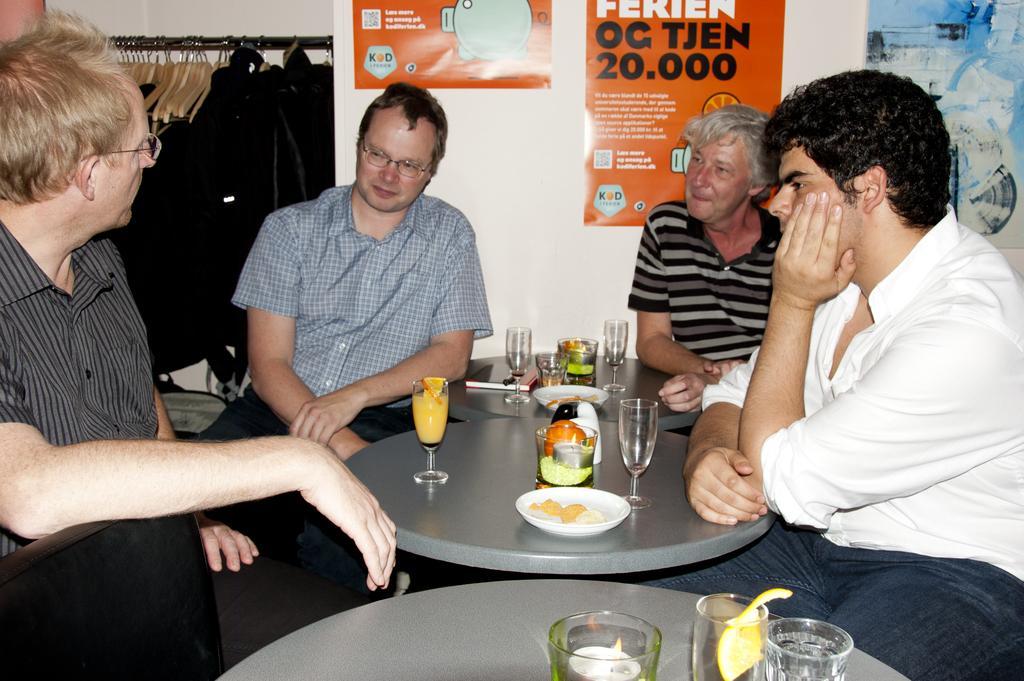In one or two sentences, can you explain what this image depicts? In this image we can see men sitting on the chairs and tables are placed in front of them. On the tables there are cutlery, crockery and a book. In the background there are clothes hanged to the hangers and advertisements pasted on the wall. 